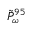Convert formula to latex. <formula><loc_0><loc_0><loc_500><loc_500>\tilde { P } _ { \omega } ^ { 9 5 }</formula> 